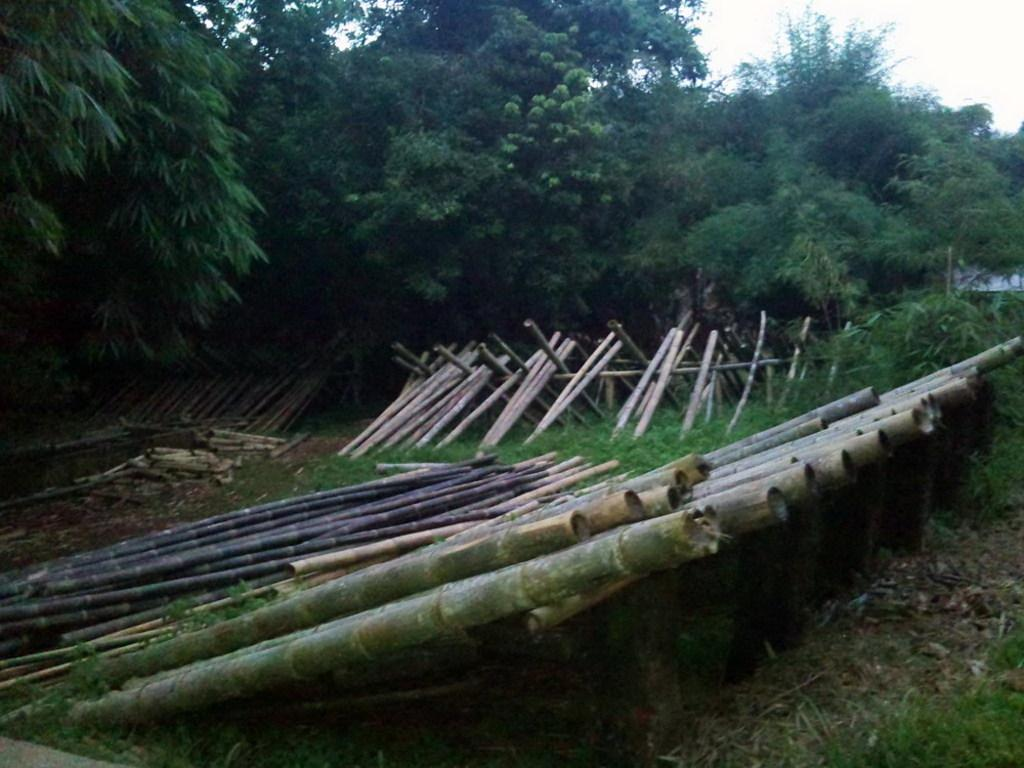What type of objects can be seen in the image? There are wooden sticks in the image. What type of natural environment is visible in the image? There is grass and trees visible in the image. What part of the natural environment is visible in the image? The sky is visible in the image. Can you see a bottle jumping in the image? There is no bottle present in the image, and therefore no such activity can be observed. 